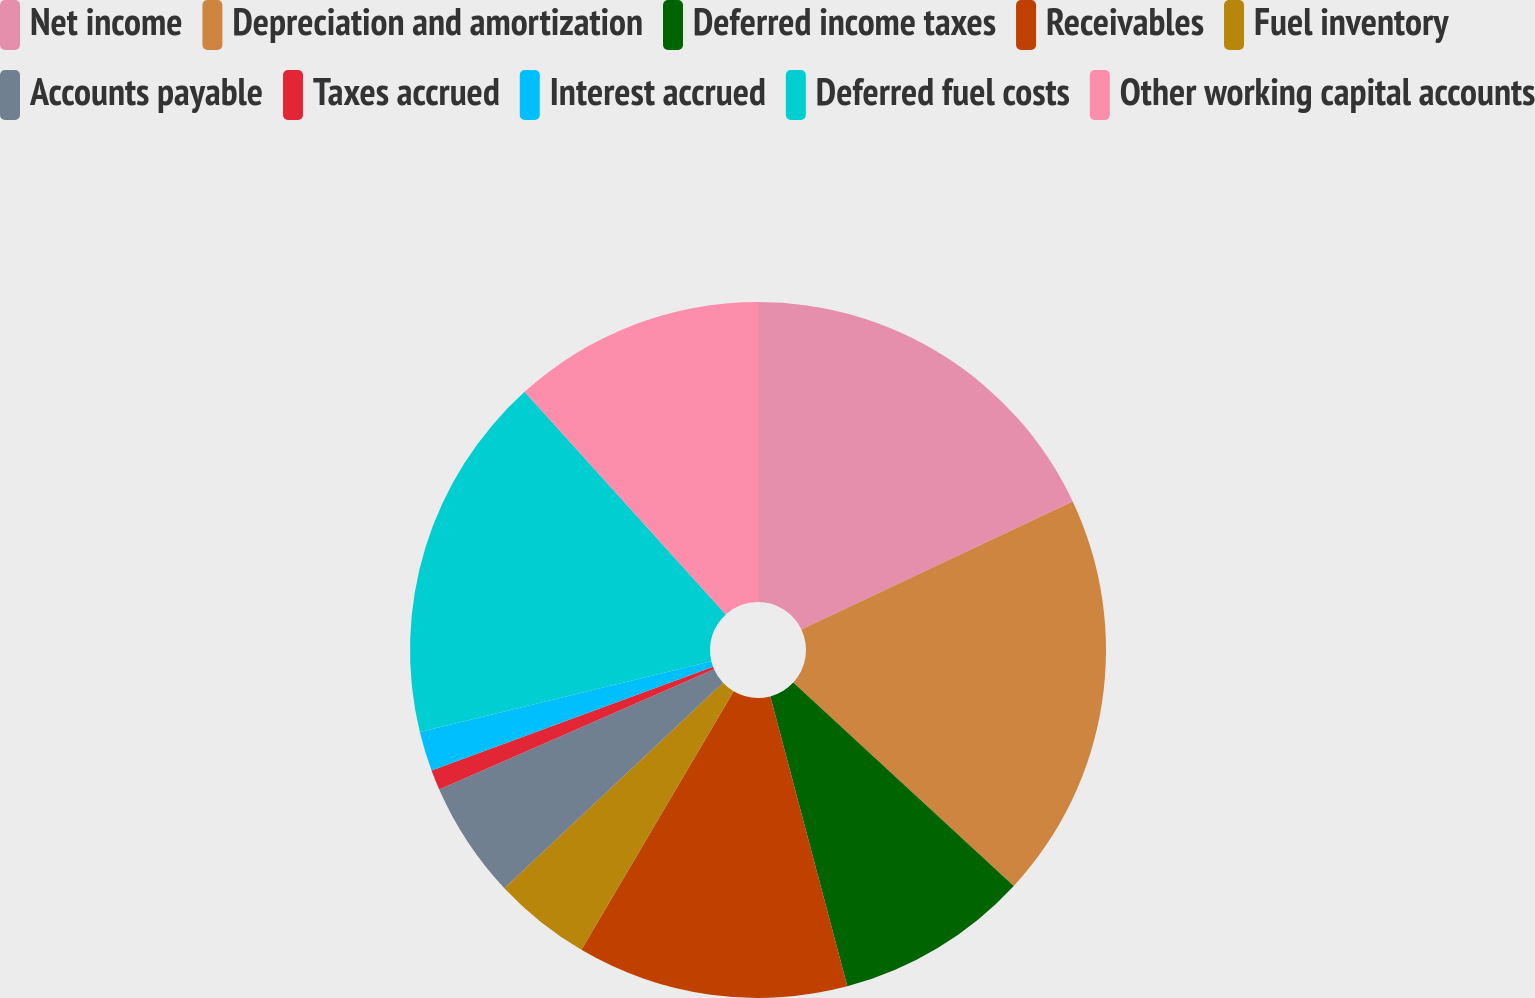Convert chart. <chart><loc_0><loc_0><loc_500><loc_500><pie_chart><fcel>Net income<fcel>Depreciation and amortization<fcel>Deferred income taxes<fcel>Receivables<fcel>Fuel inventory<fcel>Accounts payable<fcel>Taxes accrued<fcel>Interest accrued<fcel>Deferred fuel costs<fcel>Other working capital accounts<nl><fcel>17.98%<fcel>18.88%<fcel>9.01%<fcel>12.6%<fcel>4.53%<fcel>5.43%<fcel>0.94%<fcel>1.84%<fcel>17.09%<fcel>11.7%<nl></chart> 